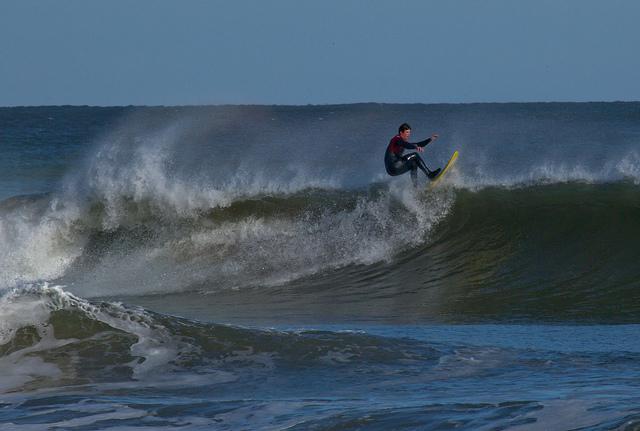Is the water placid?
Answer briefly. No. What is he doing?
Concise answer only. Surfing. What is the water temperature, based on the man's clothes?
Quick response, please. Cold. 